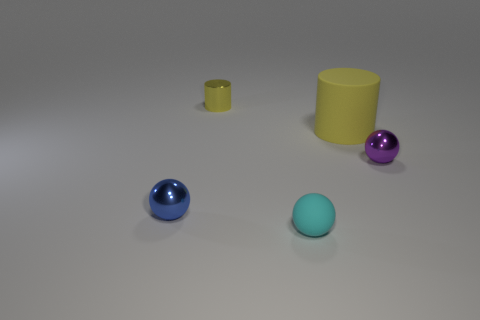What number of objects are in front of the cylinder that is left of the cylinder to the right of the small yellow object?
Give a very brief answer. 4. Is there any other thing that is the same size as the shiny cylinder?
Provide a succinct answer. Yes. Do the metal cylinder and the yellow cylinder right of the tiny metallic cylinder have the same size?
Your answer should be very brief. No. How many big purple spheres are there?
Provide a short and direct response. 0. Does the metal sphere that is on the right side of the large cylinder have the same size as the matte object that is behind the purple shiny thing?
Offer a terse response. No. There is another matte object that is the same shape as the blue object; what is its color?
Offer a very short reply. Cyan. Do the blue object and the cyan object have the same shape?
Provide a succinct answer. Yes. The metal thing that is the same shape as the big yellow rubber thing is what size?
Give a very brief answer. Small. What number of big blue spheres have the same material as the tiny purple thing?
Offer a very short reply. 0. What number of objects are either large green objects or balls?
Give a very brief answer. 3. 